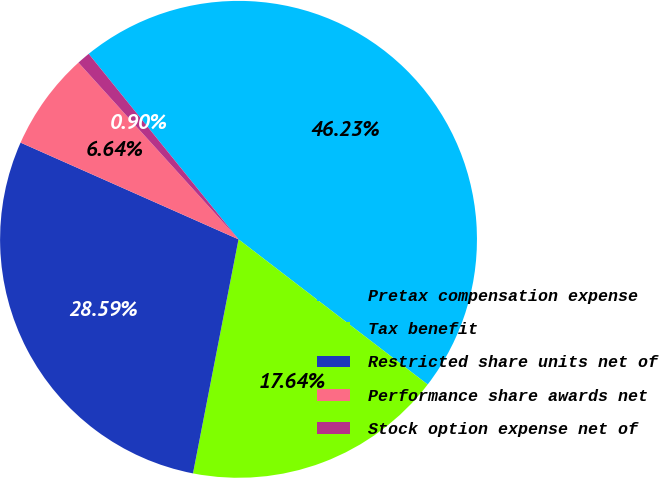Convert chart. <chart><loc_0><loc_0><loc_500><loc_500><pie_chart><fcel>Pretax compensation expense<fcel>Tax benefit<fcel>Restricted share units net of<fcel>Performance share awards net<fcel>Stock option expense net of<nl><fcel>46.23%<fcel>17.64%<fcel>28.59%<fcel>6.64%<fcel>0.9%<nl></chart> 